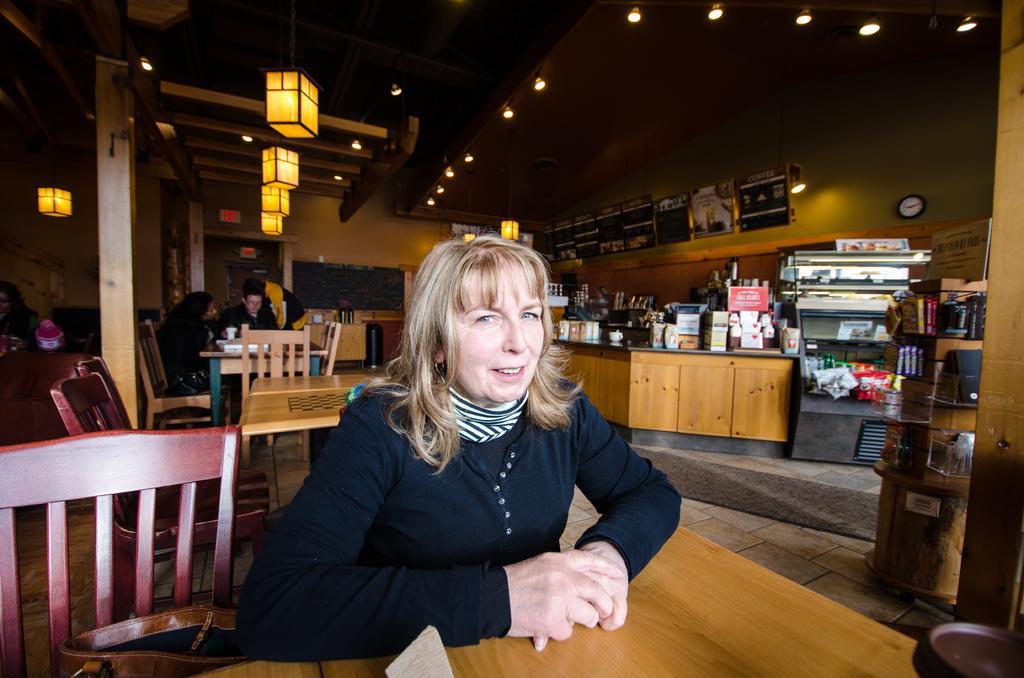Can you describe this image briefly? This is an indoor picture. At the top we can see ceiling and lights. Here we can see few boards and this is a floor. We can see persons sitting on chairs in front of a table. We can see a handbag beside to this woman. We can see a clock over a wall. 